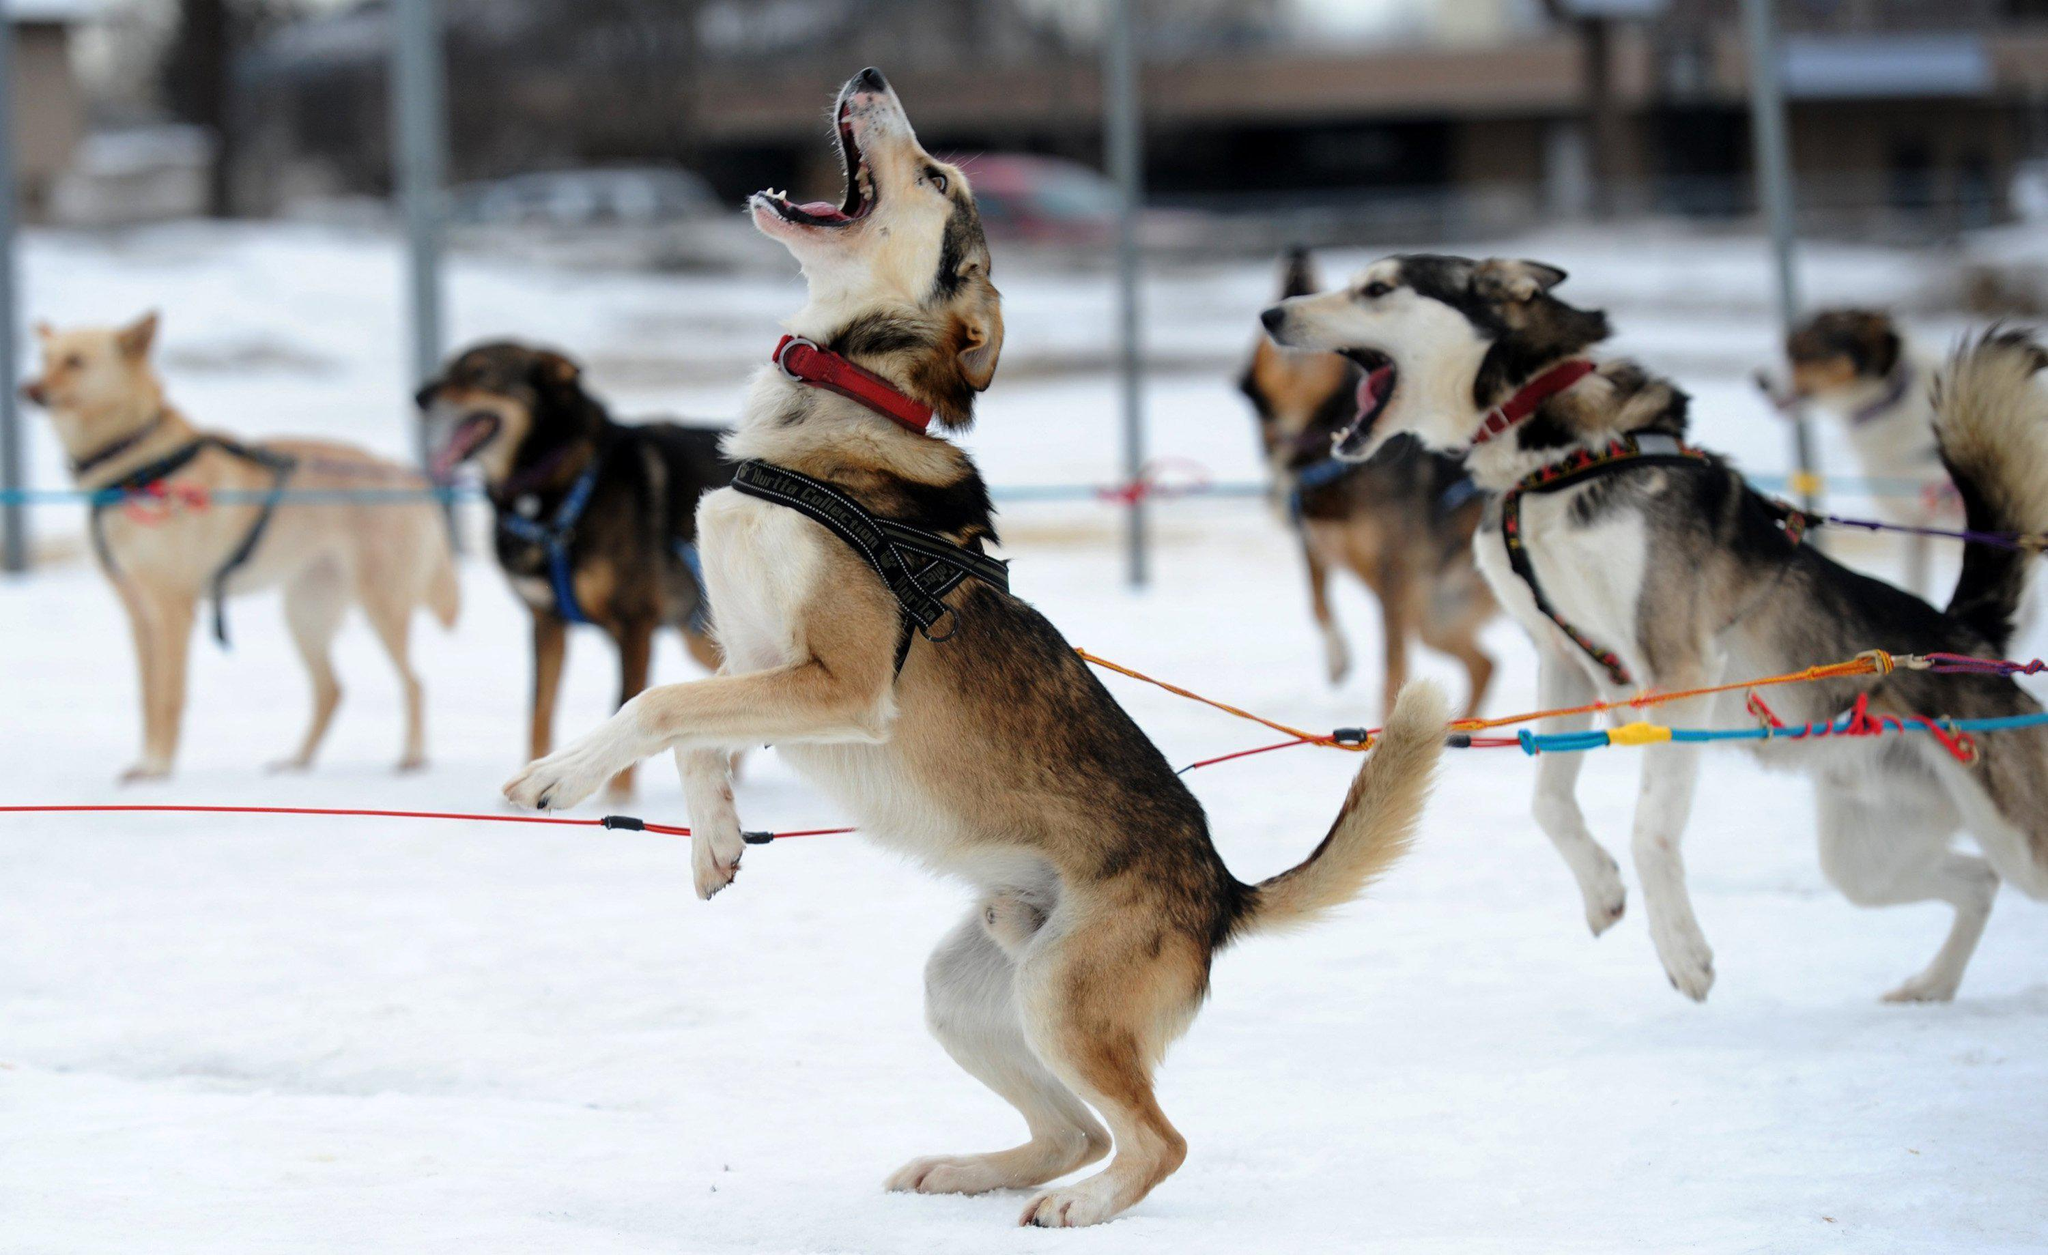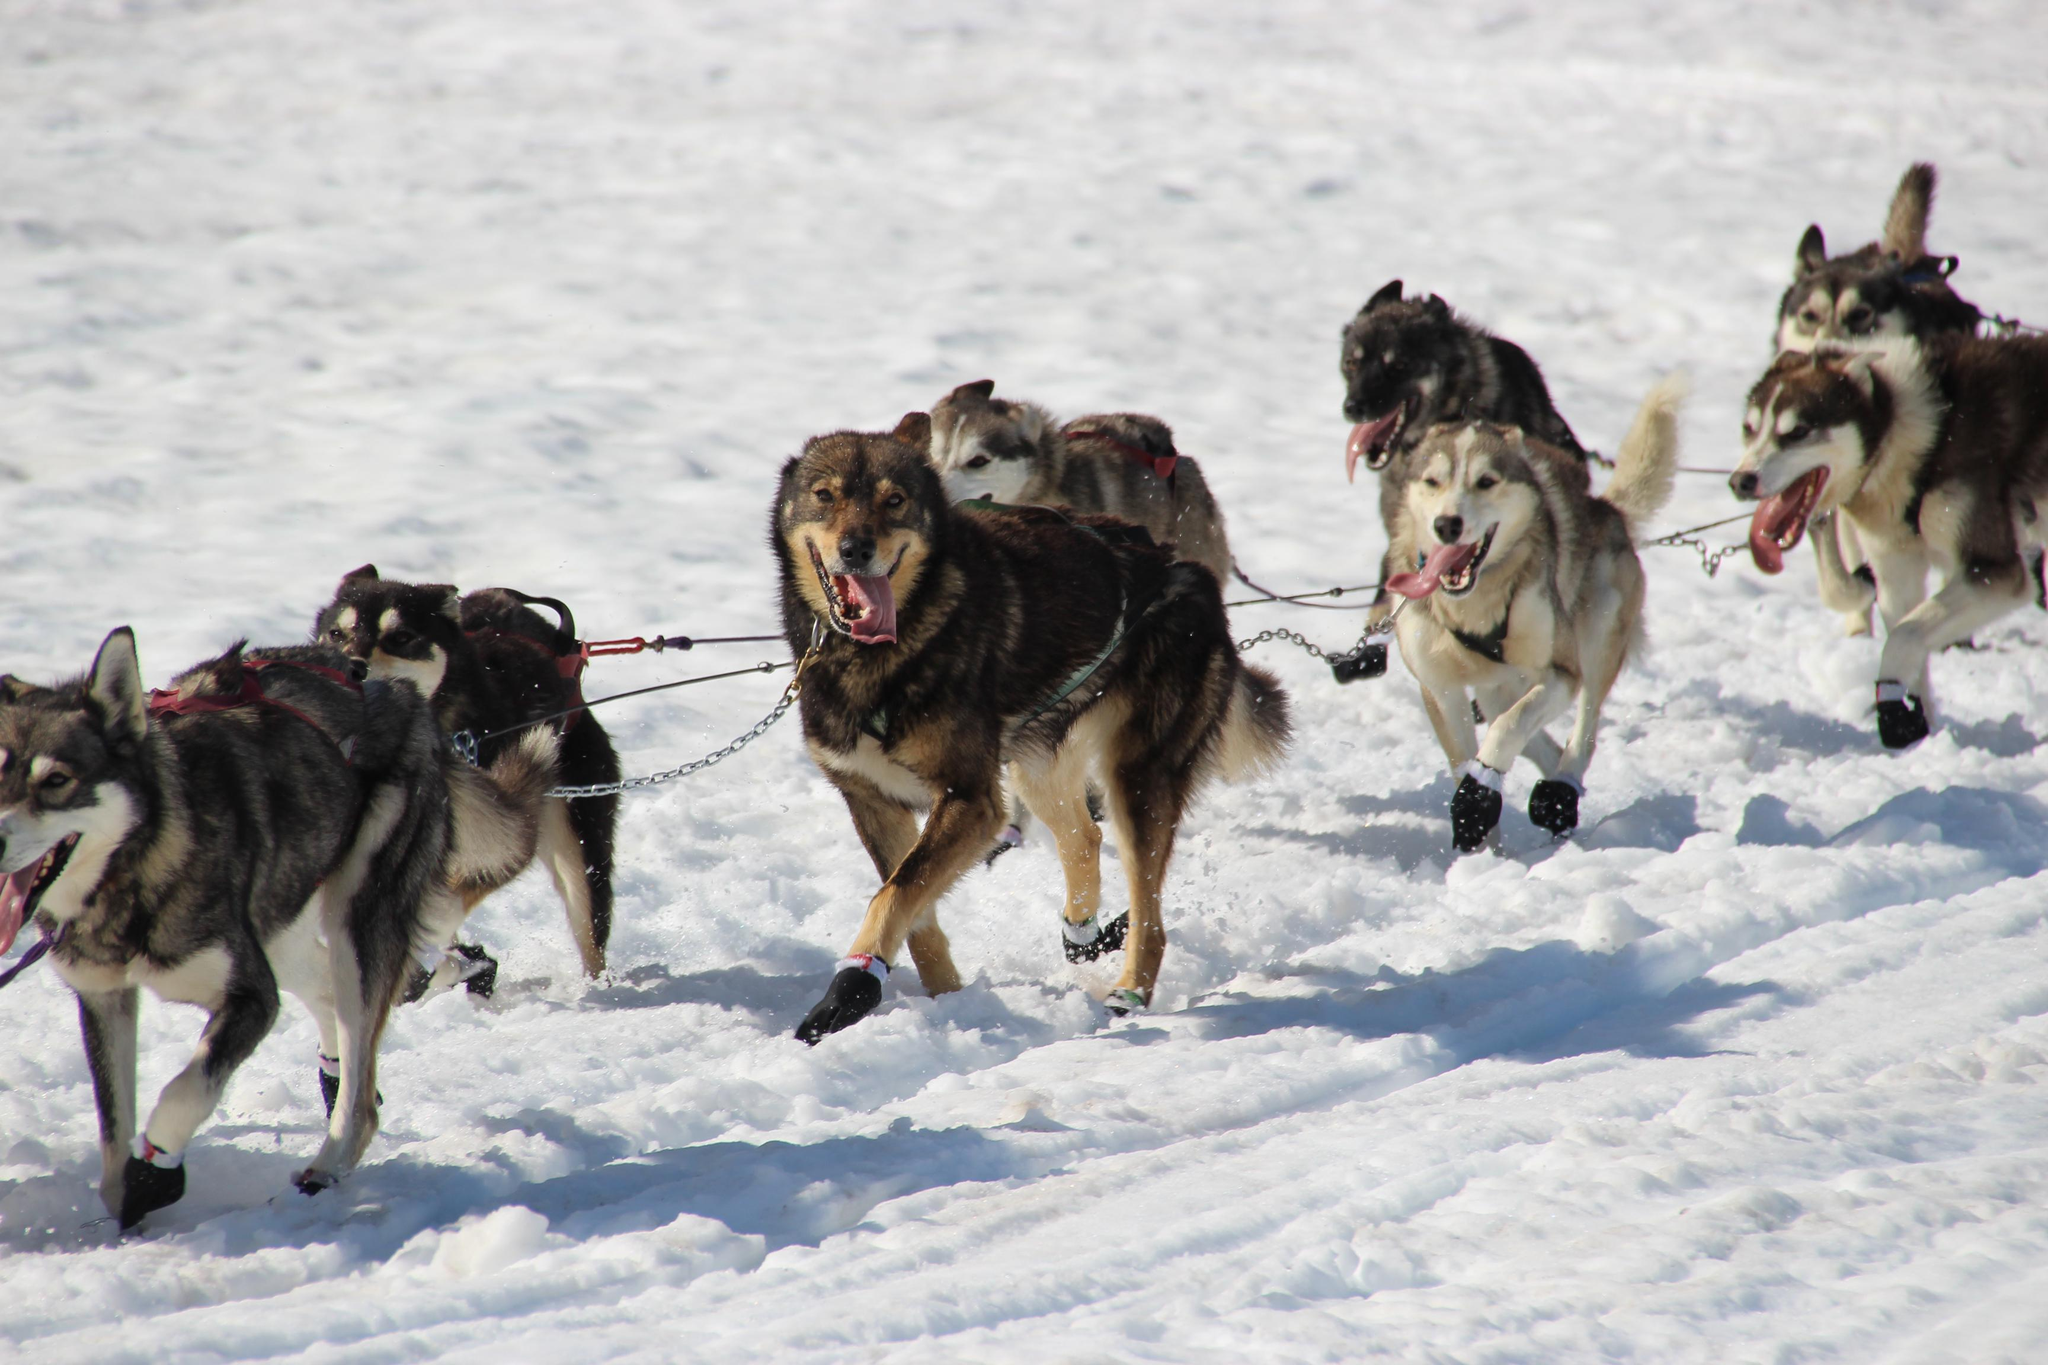The first image is the image on the left, the second image is the image on the right. For the images shown, is this caption "There are 2 people holding onto a sled." true? Answer yes or no. No. The first image is the image on the left, the second image is the image on the right. Considering the images on both sides, is "Each image shows a sled driver behind a team of dogs moving forward over snow, and a lead dog wears black booties in the team on the right." valid? Answer yes or no. No. 